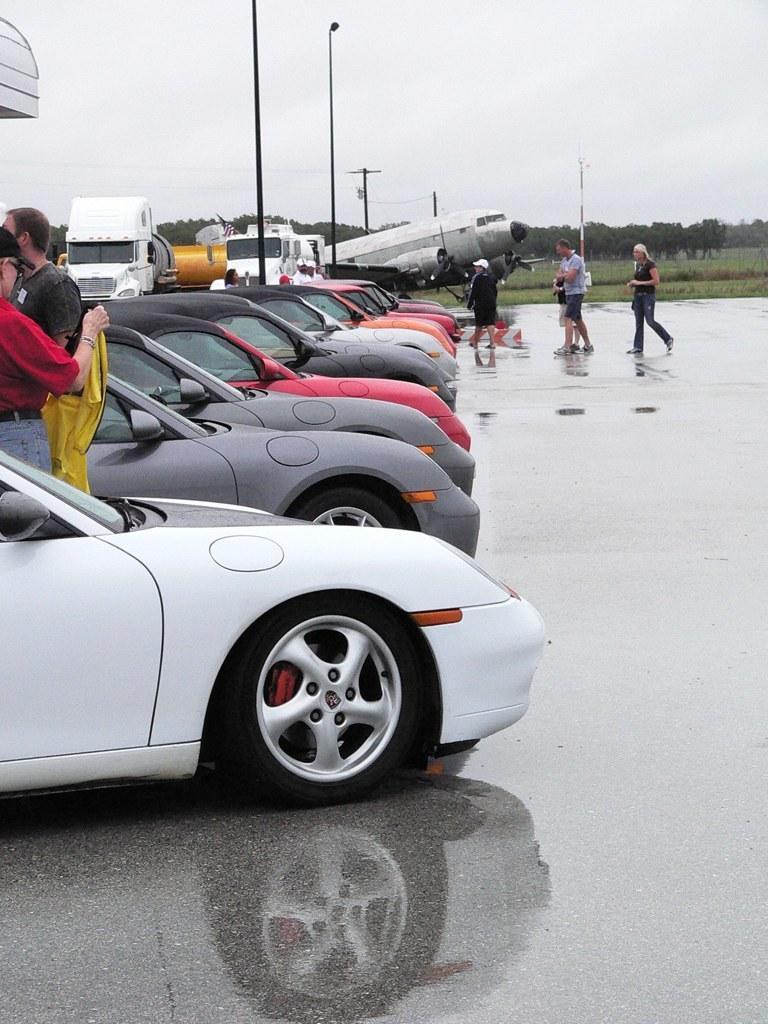Describe this image in one or two sentences. In the picture I can see the cars of different colors on the floor. I can see two men on the left side. I can see a few persons walking on the floor on the right side. In the background, I can see an airplane and trucks. I can see the poles and trees. 